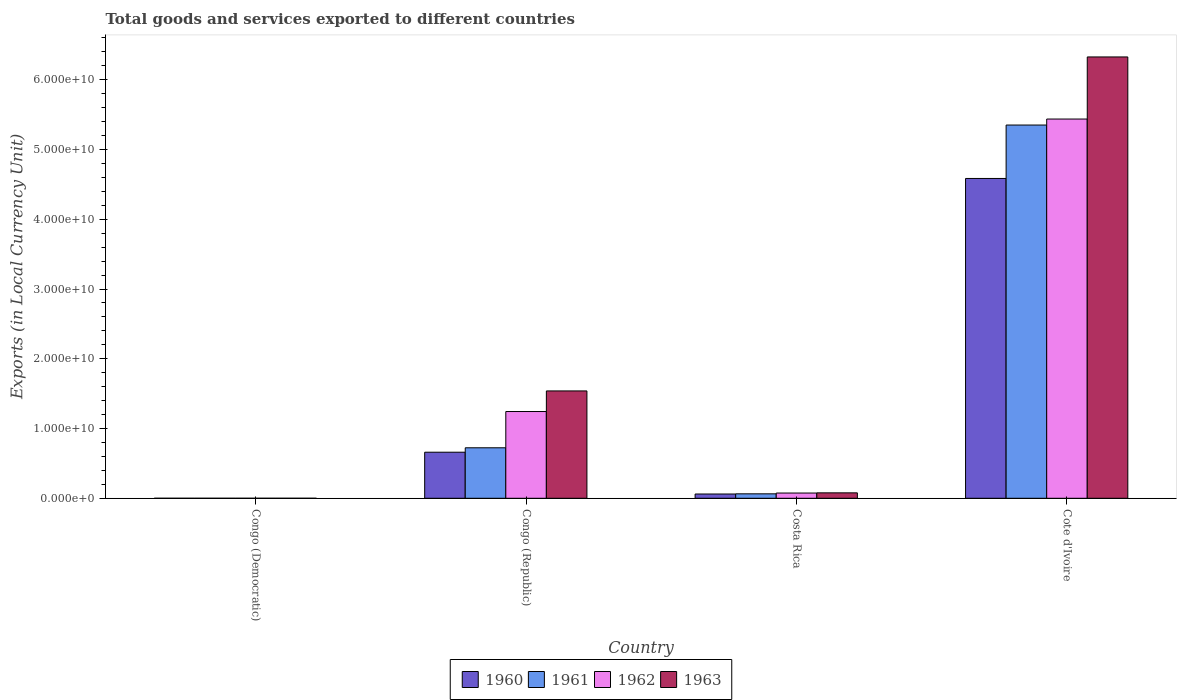Are the number of bars per tick equal to the number of legend labels?
Your answer should be very brief. Yes. Are the number of bars on each tick of the X-axis equal?
Keep it short and to the point. Yes. What is the Amount of goods and services exports in 1960 in Congo (Democratic)?
Provide a succinct answer. 0. Across all countries, what is the maximum Amount of goods and services exports in 1963?
Give a very brief answer. 6.33e+1. Across all countries, what is the minimum Amount of goods and services exports in 1963?
Your answer should be very brief. 0. In which country was the Amount of goods and services exports in 1961 maximum?
Provide a succinct answer. Cote d'Ivoire. In which country was the Amount of goods and services exports in 1960 minimum?
Your answer should be compact. Congo (Democratic). What is the total Amount of goods and services exports in 1962 in the graph?
Offer a terse response. 6.76e+1. What is the difference between the Amount of goods and services exports in 1960 in Congo (Republic) and that in Cote d'Ivoire?
Your answer should be compact. -3.92e+1. What is the difference between the Amount of goods and services exports in 1960 in Costa Rica and the Amount of goods and services exports in 1961 in Congo (Republic)?
Provide a short and direct response. -6.63e+09. What is the average Amount of goods and services exports in 1960 per country?
Provide a short and direct response. 1.33e+1. What is the difference between the Amount of goods and services exports of/in 1963 and Amount of goods and services exports of/in 1960 in Congo (Republic)?
Offer a terse response. 8.79e+09. What is the ratio of the Amount of goods and services exports in 1960 in Congo (Democratic) to that in Costa Rica?
Give a very brief answer. 1.7634647240318303e-13. What is the difference between the highest and the second highest Amount of goods and services exports in 1962?
Keep it short and to the point. 5.36e+1. What is the difference between the highest and the lowest Amount of goods and services exports in 1963?
Your response must be concise. 6.33e+1. Is the sum of the Amount of goods and services exports in 1960 in Congo (Democratic) and Congo (Republic) greater than the maximum Amount of goods and services exports in 1961 across all countries?
Ensure brevity in your answer.  No. What does the 1st bar from the left in Congo (Democratic) represents?
Provide a short and direct response. 1960. What does the 1st bar from the right in Cote d'Ivoire represents?
Your answer should be very brief. 1963. Is it the case that in every country, the sum of the Amount of goods and services exports in 1963 and Amount of goods and services exports in 1962 is greater than the Amount of goods and services exports in 1961?
Your answer should be compact. Yes. Are all the bars in the graph horizontal?
Give a very brief answer. No. Where does the legend appear in the graph?
Your response must be concise. Bottom center. What is the title of the graph?
Offer a terse response. Total goods and services exported to different countries. What is the label or title of the X-axis?
Your answer should be very brief. Country. What is the label or title of the Y-axis?
Your answer should be very brief. Exports (in Local Currency Unit). What is the Exports (in Local Currency Unit) of 1960 in Congo (Democratic)?
Make the answer very short. 0. What is the Exports (in Local Currency Unit) of 1961 in Congo (Democratic)?
Offer a terse response. 5.32500016561244e-5. What is the Exports (in Local Currency Unit) in 1962 in Congo (Democratic)?
Your answer should be very brief. 6.15126409684308e-5. What is the Exports (in Local Currency Unit) of 1963 in Congo (Democratic)?
Offer a terse response. 0. What is the Exports (in Local Currency Unit) in 1960 in Congo (Republic)?
Provide a succinct answer. 6.61e+09. What is the Exports (in Local Currency Unit) in 1961 in Congo (Republic)?
Offer a terse response. 7.24e+09. What is the Exports (in Local Currency Unit) of 1962 in Congo (Republic)?
Ensure brevity in your answer.  1.24e+1. What is the Exports (in Local Currency Unit) of 1963 in Congo (Republic)?
Your response must be concise. 1.54e+1. What is the Exports (in Local Currency Unit) of 1960 in Costa Rica?
Your answer should be very brief. 6.13e+08. What is the Exports (in Local Currency Unit) of 1961 in Costa Rica?
Ensure brevity in your answer.  6.38e+08. What is the Exports (in Local Currency Unit) in 1962 in Costa Rica?
Provide a short and direct response. 7.52e+08. What is the Exports (in Local Currency Unit) in 1963 in Costa Rica?
Your answer should be compact. 7.79e+08. What is the Exports (in Local Currency Unit) of 1960 in Cote d'Ivoire?
Provide a succinct answer. 4.59e+1. What is the Exports (in Local Currency Unit) in 1961 in Cote d'Ivoire?
Offer a terse response. 5.35e+1. What is the Exports (in Local Currency Unit) of 1962 in Cote d'Ivoire?
Make the answer very short. 5.44e+1. What is the Exports (in Local Currency Unit) of 1963 in Cote d'Ivoire?
Give a very brief answer. 6.33e+1. Across all countries, what is the maximum Exports (in Local Currency Unit) in 1960?
Provide a succinct answer. 4.59e+1. Across all countries, what is the maximum Exports (in Local Currency Unit) of 1961?
Provide a succinct answer. 5.35e+1. Across all countries, what is the maximum Exports (in Local Currency Unit) of 1962?
Give a very brief answer. 5.44e+1. Across all countries, what is the maximum Exports (in Local Currency Unit) of 1963?
Keep it short and to the point. 6.33e+1. Across all countries, what is the minimum Exports (in Local Currency Unit) of 1960?
Make the answer very short. 0. Across all countries, what is the minimum Exports (in Local Currency Unit) in 1961?
Ensure brevity in your answer.  5.32500016561244e-5. Across all countries, what is the minimum Exports (in Local Currency Unit) of 1962?
Keep it short and to the point. 6.15126409684308e-5. Across all countries, what is the minimum Exports (in Local Currency Unit) of 1963?
Provide a succinct answer. 0. What is the total Exports (in Local Currency Unit) in 1960 in the graph?
Your answer should be compact. 5.31e+1. What is the total Exports (in Local Currency Unit) in 1961 in the graph?
Give a very brief answer. 6.14e+1. What is the total Exports (in Local Currency Unit) in 1962 in the graph?
Your answer should be very brief. 6.76e+1. What is the total Exports (in Local Currency Unit) of 1963 in the graph?
Ensure brevity in your answer.  7.94e+1. What is the difference between the Exports (in Local Currency Unit) of 1960 in Congo (Democratic) and that in Congo (Republic)?
Keep it short and to the point. -6.61e+09. What is the difference between the Exports (in Local Currency Unit) of 1961 in Congo (Democratic) and that in Congo (Republic)?
Keep it short and to the point. -7.24e+09. What is the difference between the Exports (in Local Currency Unit) of 1962 in Congo (Democratic) and that in Congo (Republic)?
Make the answer very short. -1.24e+1. What is the difference between the Exports (in Local Currency Unit) of 1963 in Congo (Democratic) and that in Congo (Republic)?
Offer a very short reply. -1.54e+1. What is the difference between the Exports (in Local Currency Unit) in 1960 in Congo (Democratic) and that in Costa Rica?
Make the answer very short. -6.13e+08. What is the difference between the Exports (in Local Currency Unit) in 1961 in Congo (Democratic) and that in Costa Rica?
Offer a terse response. -6.38e+08. What is the difference between the Exports (in Local Currency Unit) of 1962 in Congo (Democratic) and that in Costa Rica?
Make the answer very short. -7.52e+08. What is the difference between the Exports (in Local Currency Unit) in 1963 in Congo (Democratic) and that in Costa Rica?
Provide a succinct answer. -7.79e+08. What is the difference between the Exports (in Local Currency Unit) of 1960 in Congo (Democratic) and that in Cote d'Ivoire?
Give a very brief answer. -4.59e+1. What is the difference between the Exports (in Local Currency Unit) of 1961 in Congo (Democratic) and that in Cote d'Ivoire?
Your answer should be compact. -5.35e+1. What is the difference between the Exports (in Local Currency Unit) of 1962 in Congo (Democratic) and that in Cote d'Ivoire?
Your answer should be very brief. -5.44e+1. What is the difference between the Exports (in Local Currency Unit) in 1963 in Congo (Democratic) and that in Cote d'Ivoire?
Your answer should be compact. -6.33e+1. What is the difference between the Exports (in Local Currency Unit) of 1960 in Congo (Republic) and that in Costa Rica?
Ensure brevity in your answer.  5.99e+09. What is the difference between the Exports (in Local Currency Unit) of 1961 in Congo (Republic) and that in Costa Rica?
Give a very brief answer. 6.60e+09. What is the difference between the Exports (in Local Currency Unit) in 1962 in Congo (Republic) and that in Costa Rica?
Your response must be concise. 1.17e+1. What is the difference between the Exports (in Local Currency Unit) of 1963 in Congo (Republic) and that in Costa Rica?
Provide a succinct answer. 1.46e+1. What is the difference between the Exports (in Local Currency Unit) in 1960 in Congo (Republic) and that in Cote d'Ivoire?
Keep it short and to the point. -3.92e+1. What is the difference between the Exports (in Local Currency Unit) in 1961 in Congo (Republic) and that in Cote d'Ivoire?
Ensure brevity in your answer.  -4.63e+1. What is the difference between the Exports (in Local Currency Unit) of 1962 in Congo (Republic) and that in Cote d'Ivoire?
Offer a very short reply. -4.19e+1. What is the difference between the Exports (in Local Currency Unit) of 1963 in Congo (Republic) and that in Cote d'Ivoire?
Keep it short and to the point. -4.79e+1. What is the difference between the Exports (in Local Currency Unit) in 1960 in Costa Rica and that in Cote d'Ivoire?
Provide a succinct answer. -4.52e+1. What is the difference between the Exports (in Local Currency Unit) in 1961 in Costa Rica and that in Cote d'Ivoire?
Your answer should be very brief. -5.29e+1. What is the difference between the Exports (in Local Currency Unit) of 1962 in Costa Rica and that in Cote d'Ivoire?
Give a very brief answer. -5.36e+1. What is the difference between the Exports (in Local Currency Unit) of 1963 in Costa Rica and that in Cote d'Ivoire?
Your answer should be very brief. -6.25e+1. What is the difference between the Exports (in Local Currency Unit) in 1960 in Congo (Democratic) and the Exports (in Local Currency Unit) in 1961 in Congo (Republic)?
Make the answer very short. -7.24e+09. What is the difference between the Exports (in Local Currency Unit) of 1960 in Congo (Democratic) and the Exports (in Local Currency Unit) of 1962 in Congo (Republic)?
Your answer should be very brief. -1.24e+1. What is the difference between the Exports (in Local Currency Unit) in 1960 in Congo (Democratic) and the Exports (in Local Currency Unit) in 1963 in Congo (Republic)?
Keep it short and to the point. -1.54e+1. What is the difference between the Exports (in Local Currency Unit) in 1961 in Congo (Democratic) and the Exports (in Local Currency Unit) in 1962 in Congo (Republic)?
Provide a short and direct response. -1.24e+1. What is the difference between the Exports (in Local Currency Unit) in 1961 in Congo (Democratic) and the Exports (in Local Currency Unit) in 1963 in Congo (Republic)?
Keep it short and to the point. -1.54e+1. What is the difference between the Exports (in Local Currency Unit) of 1962 in Congo (Democratic) and the Exports (in Local Currency Unit) of 1963 in Congo (Republic)?
Provide a short and direct response. -1.54e+1. What is the difference between the Exports (in Local Currency Unit) in 1960 in Congo (Democratic) and the Exports (in Local Currency Unit) in 1961 in Costa Rica?
Keep it short and to the point. -6.38e+08. What is the difference between the Exports (in Local Currency Unit) of 1960 in Congo (Democratic) and the Exports (in Local Currency Unit) of 1962 in Costa Rica?
Give a very brief answer. -7.52e+08. What is the difference between the Exports (in Local Currency Unit) in 1960 in Congo (Democratic) and the Exports (in Local Currency Unit) in 1963 in Costa Rica?
Keep it short and to the point. -7.79e+08. What is the difference between the Exports (in Local Currency Unit) in 1961 in Congo (Democratic) and the Exports (in Local Currency Unit) in 1962 in Costa Rica?
Your answer should be very brief. -7.52e+08. What is the difference between the Exports (in Local Currency Unit) of 1961 in Congo (Democratic) and the Exports (in Local Currency Unit) of 1963 in Costa Rica?
Make the answer very short. -7.79e+08. What is the difference between the Exports (in Local Currency Unit) in 1962 in Congo (Democratic) and the Exports (in Local Currency Unit) in 1963 in Costa Rica?
Provide a short and direct response. -7.79e+08. What is the difference between the Exports (in Local Currency Unit) of 1960 in Congo (Democratic) and the Exports (in Local Currency Unit) of 1961 in Cote d'Ivoire?
Offer a terse response. -5.35e+1. What is the difference between the Exports (in Local Currency Unit) in 1960 in Congo (Democratic) and the Exports (in Local Currency Unit) in 1962 in Cote d'Ivoire?
Your answer should be very brief. -5.44e+1. What is the difference between the Exports (in Local Currency Unit) in 1960 in Congo (Democratic) and the Exports (in Local Currency Unit) in 1963 in Cote d'Ivoire?
Offer a very short reply. -6.33e+1. What is the difference between the Exports (in Local Currency Unit) in 1961 in Congo (Democratic) and the Exports (in Local Currency Unit) in 1962 in Cote d'Ivoire?
Your response must be concise. -5.44e+1. What is the difference between the Exports (in Local Currency Unit) of 1961 in Congo (Democratic) and the Exports (in Local Currency Unit) of 1963 in Cote d'Ivoire?
Provide a short and direct response. -6.33e+1. What is the difference between the Exports (in Local Currency Unit) in 1962 in Congo (Democratic) and the Exports (in Local Currency Unit) in 1963 in Cote d'Ivoire?
Give a very brief answer. -6.33e+1. What is the difference between the Exports (in Local Currency Unit) of 1960 in Congo (Republic) and the Exports (in Local Currency Unit) of 1961 in Costa Rica?
Ensure brevity in your answer.  5.97e+09. What is the difference between the Exports (in Local Currency Unit) of 1960 in Congo (Republic) and the Exports (in Local Currency Unit) of 1962 in Costa Rica?
Offer a very short reply. 5.85e+09. What is the difference between the Exports (in Local Currency Unit) of 1960 in Congo (Republic) and the Exports (in Local Currency Unit) of 1963 in Costa Rica?
Your response must be concise. 5.83e+09. What is the difference between the Exports (in Local Currency Unit) in 1961 in Congo (Republic) and the Exports (in Local Currency Unit) in 1962 in Costa Rica?
Your answer should be compact. 6.49e+09. What is the difference between the Exports (in Local Currency Unit) in 1961 in Congo (Republic) and the Exports (in Local Currency Unit) in 1963 in Costa Rica?
Keep it short and to the point. 6.46e+09. What is the difference between the Exports (in Local Currency Unit) in 1962 in Congo (Republic) and the Exports (in Local Currency Unit) in 1963 in Costa Rica?
Provide a short and direct response. 1.17e+1. What is the difference between the Exports (in Local Currency Unit) in 1960 in Congo (Republic) and the Exports (in Local Currency Unit) in 1961 in Cote d'Ivoire?
Make the answer very short. -4.69e+1. What is the difference between the Exports (in Local Currency Unit) in 1960 in Congo (Republic) and the Exports (in Local Currency Unit) in 1962 in Cote d'Ivoire?
Make the answer very short. -4.78e+1. What is the difference between the Exports (in Local Currency Unit) in 1960 in Congo (Republic) and the Exports (in Local Currency Unit) in 1963 in Cote d'Ivoire?
Your answer should be compact. -5.67e+1. What is the difference between the Exports (in Local Currency Unit) of 1961 in Congo (Republic) and the Exports (in Local Currency Unit) of 1962 in Cote d'Ivoire?
Give a very brief answer. -4.71e+1. What is the difference between the Exports (in Local Currency Unit) of 1961 in Congo (Republic) and the Exports (in Local Currency Unit) of 1963 in Cote d'Ivoire?
Your answer should be very brief. -5.60e+1. What is the difference between the Exports (in Local Currency Unit) in 1962 in Congo (Republic) and the Exports (in Local Currency Unit) in 1963 in Cote d'Ivoire?
Your answer should be very brief. -5.08e+1. What is the difference between the Exports (in Local Currency Unit) in 1960 in Costa Rica and the Exports (in Local Currency Unit) in 1961 in Cote d'Ivoire?
Make the answer very short. -5.29e+1. What is the difference between the Exports (in Local Currency Unit) of 1960 in Costa Rica and the Exports (in Local Currency Unit) of 1962 in Cote d'Ivoire?
Ensure brevity in your answer.  -5.38e+1. What is the difference between the Exports (in Local Currency Unit) of 1960 in Costa Rica and the Exports (in Local Currency Unit) of 1963 in Cote d'Ivoire?
Ensure brevity in your answer.  -6.27e+1. What is the difference between the Exports (in Local Currency Unit) of 1961 in Costa Rica and the Exports (in Local Currency Unit) of 1962 in Cote d'Ivoire?
Give a very brief answer. -5.37e+1. What is the difference between the Exports (in Local Currency Unit) of 1961 in Costa Rica and the Exports (in Local Currency Unit) of 1963 in Cote d'Ivoire?
Your response must be concise. -6.26e+1. What is the difference between the Exports (in Local Currency Unit) of 1962 in Costa Rica and the Exports (in Local Currency Unit) of 1963 in Cote d'Ivoire?
Your response must be concise. -6.25e+1. What is the average Exports (in Local Currency Unit) in 1960 per country?
Ensure brevity in your answer.  1.33e+1. What is the average Exports (in Local Currency Unit) in 1961 per country?
Give a very brief answer. 1.53e+1. What is the average Exports (in Local Currency Unit) in 1962 per country?
Offer a terse response. 1.69e+1. What is the average Exports (in Local Currency Unit) in 1963 per country?
Ensure brevity in your answer.  1.99e+1. What is the difference between the Exports (in Local Currency Unit) in 1960 and Exports (in Local Currency Unit) in 1962 in Congo (Democratic)?
Offer a terse response. 0. What is the difference between the Exports (in Local Currency Unit) in 1960 and Exports (in Local Currency Unit) in 1963 in Congo (Democratic)?
Provide a succinct answer. -0. What is the difference between the Exports (in Local Currency Unit) in 1961 and Exports (in Local Currency Unit) in 1963 in Congo (Democratic)?
Provide a succinct answer. -0. What is the difference between the Exports (in Local Currency Unit) in 1962 and Exports (in Local Currency Unit) in 1963 in Congo (Democratic)?
Provide a succinct answer. -0. What is the difference between the Exports (in Local Currency Unit) of 1960 and Exports (in Local Currency Unit) of 1961 in Congo (Republic)?
Ensure brevity in your answer.  -6.33e+08. What is the difference between the Exports (in Local Currency Unit) in 1960 and Exports (in Local Currency Unit) in 1962 in Congo (Republic)?
Your answer should be very brief. -5.83e+09. What is the difference between the Exports (in Local Currency Unit) in 1960 and Exports (in Local Currency Unit) in 1963 in Congo (Republic)?
Give a very brief answer. -8.79e+09. What is the difference between the Exports (in Local Currency Unit) of 1961 and Exports (in Local Currency Unit) of 1962 in Congo (Republic)?
Offer a very short reply. -5.20e+09. What is the difference between the Exports (in Local Currency Unit) of 1961 and Exports (in Local Currency Unit) of 1963 in Congo (Republic)?
Your answer should be very brief. -8.15e+09. What is the difference between the Exports (in Local Currency Unit) in 1962 and Exports (in Local Currency Unit) in 1963 in Congo (Republic)?
Offer a terse response. -2.95e+09. What is the difference between the Exports (in Local Currency Unit) in 1960 and Exports (in Local Currency Unit) in 1961 in Costa Rica?
Keep it short and to the point. -2.54e+07. What is the difference between the Exports (in Local Currency Unit) in 1960 and Exports (in Local Currency Unit) in 1962 in Costa Rica?
Provide a short and direct response. -1.39e+08. What is the difference between the Exports (in Local Currency Unit) in 1960 and Exports (in Local Currency Unit) in 1963 in Costa Rica?
Give a very brief answer. -1.66e+08. What is the difference between the Exports (in Local Currency Unit) of 1961 and Exports (in Local Currency Unit) of 1962 in Costa Rica?
Your response must be concise. -1.14e+08. What is the difference between the Exports (in Local Currency Unit) in 1961 and Exports (in Local Currency Unit) in 1963 in Costa Rica?
Your response must be concise. -1.41e+08. What is the difference between the Exports (in Local Currency Unit) in 1962 and Exports (in Local Currency Unit) in 1963 in Costa Rica?
Offer a very short reply. -2.71e+07. What is the difference between the Exports (in Local Currency Unit) of 1960 and Exports (in Local Currency Unit) of 1961 in Cote d'Ivoire?
Keep it short and to the point. -7.66e+09. What is the difference between the Exports (in Local Currency Unit) of 1960 and Exports (in Local Currency Unit) of 1962 in Cote d'Ivoire?
Keep it short and to the point. -8.52e+09. What is the difference between the Exports (in Local Currency Unit) in 1960 and Exports (in Local Currency Unit) in 1963 in Cote d'Ivoire?
Your answer should be compact. -1.74e+1. What is the difference between the Exports (in Local Currency Unit) of 1961 and Exports (in Local Currency Unit) of 1962 in Cote d'Ivoire?
Provide a succinct answer. -8.62e+08. What is the difference between the Exports (in Local Currency Unit) of 1961 and Exports (in Local Currency Unit) of 1963 in Cote d'Ivoire?
Offer a very short reply. -9.76e+09. What is the difference between the Exports (in Local Currency Unit) of 1962 and Exports (in Local Currency Unit) of 1963 in Cote d'Ivoire?
Offer a very short reply. -8.90e+09. What is the ratio of the Exports (in Local Currency Unit) of 1960 in Congo (Democratic) to that in Congo (Republic)?
Your answer should be compact. 0. What is the ratio of the Exports (in Local Currency Unit) in 1961 in Congo (Democratic) to that in Congo (Republic)?
Ensure brevity in your answer.  0. What is the ratio of the Exports (in Local Currency Unit) of 1962 in Congo (Democratic) to that in Congo (Republic)?
Your response must be concise. 0. What is the ratio of the Exports (in Local Currency Unit) of 1963 in Congo (Democratic) to that in Congo (Republic)?
Provide a succinct answer. 0. What is the ratio of the Exports (in Local Currency Unit) of 1962 in Congo (Democratic) to that in Costa Rica?
Offer a very short reply. 0. What is the ratio of the Exports (in Local Currency Unit) of 1963 in Congo (Democratic) to that in Cote d'Ivoire?
Provide a short and direct response. 0. What is the ratio of the Exports (in Local Currency Unit) of 1960 in Congo (Republic) to that in Costa Rica?
Give a very brief answer. 10.78. What is the ratio of the Exports (in Local Currency Unit) in 1961 in Congo (Republic) to that in Costa Rica?
Your response must be concise. 11.35. What is the ratio of the Exports (in Local Currency Unit) in 1962 in Congo (Republic) to that in Costa Rica?
Ensure brevity in your answer.  16.55. What is the ratio of the Exports (in Local Currency Unit) of 1963 in Congo (Republic) to that in Costa Rica?
Ensure brevity in your answer.  19.76. What is the ratio of the Exports (in Local Currency Unit) in 1960 in Congo (Republic) to that in Cote d'Ivoire?
Provide a short and direct response. 0.14. What is the ratio of the Exports (in Local Currency Unit) of 1961 in Congo (Republic) to that in Cote d'Ivoire?
Your answer should be compact. 0.14. What is the ratio of the Exports (in Local Currency Unit) of 1962 in Congo (Republic) to that in Cote d'Ivoire?
Make the answer very short. 0.23. What is the ratio of the Exports (in Local Currency Unit) of 1963 in Congo (Republic) to that in Cote d'Ivoire?
Your response must be concise. 0.24. What is the ratio of the Exports (in Local Currency Unit) in 1960 in Costa Rica to that in Cote d'Ivoire?
Provide a short and direct response. 0.01. What is the ratio of the Exports (in Local Currency Unit) of 1961 in Costa Rica to that in Cote d'Ivoire?
Your answer should be very brief. 0.01. What is the ratio of the Exports (in Local Currency Unit) in 1962 in Costa Rica to that in Cote d'Ivoire?
Provide a short and direct response. 0.01. What is the ratio of the Exports (in Local Currency Unit) in 1963 in Costa Rica to that in Cote d'Ivoire?
Provide a succinct answer. 0.01. What is the difference between the highest and the second highest Exports (in Local Currency Unit) in 1960?
Keep it short and to the point. 3.92e+1. What is the difference between the highest and the second highest Exports (in Local Currency Unit) of 1961?
Give a very brief answer. 4.63e+1. What is the difference between the highest and the second highest Exports (in Local Currency Unit) in 1962?
Your response must be concise. 4.19e+1. What is the difference between the highest and the second highest Exports (in Local Currency Unit) of 1963?
Give a very brief answer. 4.79e+1. What is the difference between the highest and the lowest Exports (in Local Currency Unit) of 1960?
Give a very brief answer. 4.59e+1. What is the difference between the highest and the lowest Exports (in Local Currency Unit) of 1961?
Provide a short and direct response. 5.35e+1. What is the difference between the highest and the lowest Exports (in Local Currency Unit) in 1962?
Your answer should be very brief. 5.44e+1. What is the difference between the highest and the lowest Exports (in Local Currency Unit) of 1963?
Make the answer very short. 6.33e+1. 